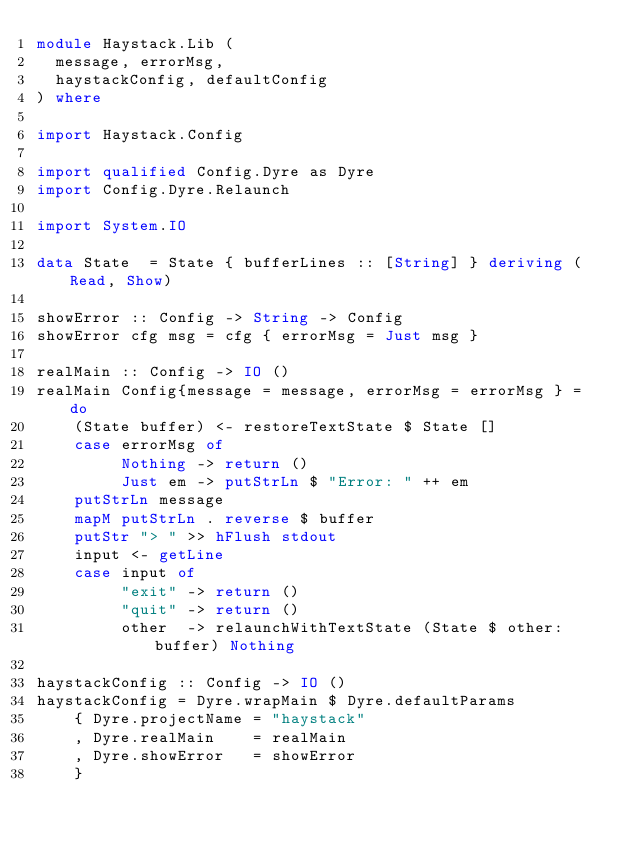<code> <loc_0><loc_0><loc_500><loc_500><_Haskell_>module Haystack.Lib (
  message, errorMsg,
  haystackConfig, defaultConfig
) where

import Haystack.Config

import qualified Config.Dyre as Dyre
import Config.Dyre.Relaunch

import System.IO

data State  = State { bufferLines :: [String] } deriving (Read, Show)

showError :: Config -> String -> Config
showError cfg msg = cfg { errorMsg = Just msg }

realMain :: Config -> IO ()
realMain Config{message = message, errorMsg = errorMsg } = do
    (State buffer) <- restoreTextState $ State []
    case errorMsg of
         Nothing -> return ()
         Just em -> putStrLn $ "Error: " ++ em
    putStrLn message
    mapM putStrLn . reverse $ buffer
    putStr "> " >> hFlush stdout
    input <- getLine
    case input of
         "exit" -> return ()
         "quit" -> return ()
         other  -> relaunchWithTextState (State $ other:buffer) Nothing

haystackConfig :: Config -> IO ()
haystackConfig = Dyre.wrapMain $ Dyre.defaultParams
    { Dyre.projectName = "haystack"
    , Dyre.realMain    = realMain
    , Dyre.showError   = showError
    }
</code> 